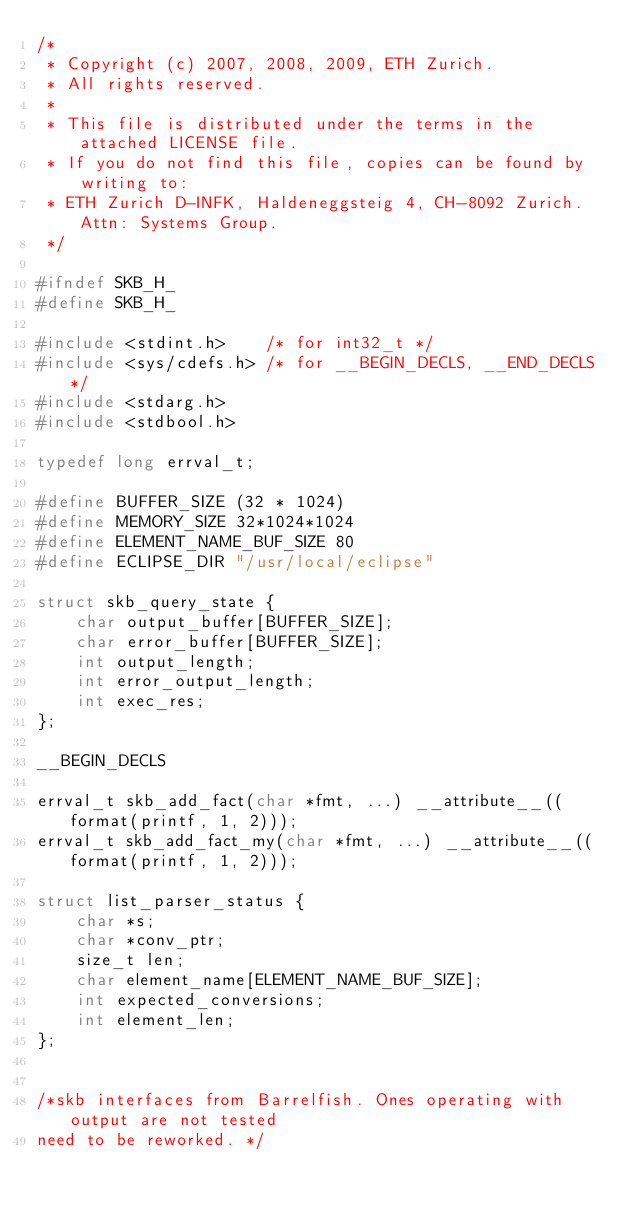<code> <loc_0><loc_0><loc_500><loc_500><_C_>/*
 * Copyright (c) 2007, 2008, 2009, ETH Zurich.
 * All rights reserved.
 *
 * This file is distributed under the terms in the attached LICENSE file.
 * If you do not find this file, copies can be found by writing to:
 * ETH Zurich D-INFK, Haldeneggsteig 4, CH-8092 Zurich. Attn: Systems Group.
 */

#ifndef SKB_H_
#define SKB_H_

#include <stdint.h>    /* for int32_t */
#include <sys/cdefs.h> /* for __BEGIN_DECLS, __END_DECLS */
#include <stdarg.h>
#include <stdbool.h>

typedef long errval_t;

#define BUFFER_SIZE (32 * 1024)
#define MEMORY_SIZE 32*1024*1024
#define ELEMENT_NAME_BUF_SIZE 80
#define ECLIPSE_DIR "/usr/local/eclipse"

struct skb_query_state {
    char output_buffer[BUFFER_SIZE];
    char error_buffer[BUFFER_SIZE];
    int output_length;
    int error_output_length;
    int exec_res;
};

__BEGIN_DECLS

errval_t skb_add_fact(char *fmt, ...) __attribute__((format(printf, 1, 2)));
errval_t skb_add_fact_my(char *fmt, ...) __attribute__((format(printf, 1, 2)));

struct list_parser_status {
    char *s;
    char *conv_ptr;
    size_t len;
    char element_name[ELEMENT_NAME_BUF_SIZE];
    int expected_conversions;
    int element_len;
};


/*skb interfaces from Barrelfish. Ones operating with output are not tested 
need to be reworked. */</code> 